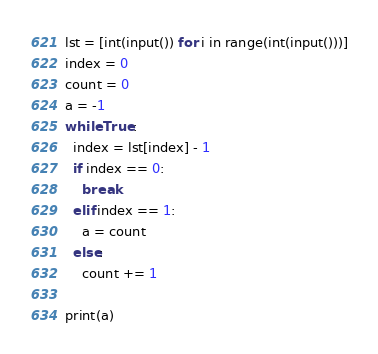<code> <loc_0><loc_0><loc_500><loc_500><_Python_>lst = [int(input()) for i in range(int(input()))]
index = 0
count = 0
a = -1
while True:
  index = lst[index] - 1
  if index == 0:
    break
  elif index == 1:
    a = count
  else:
    count += 1
    
print(a)</code> 